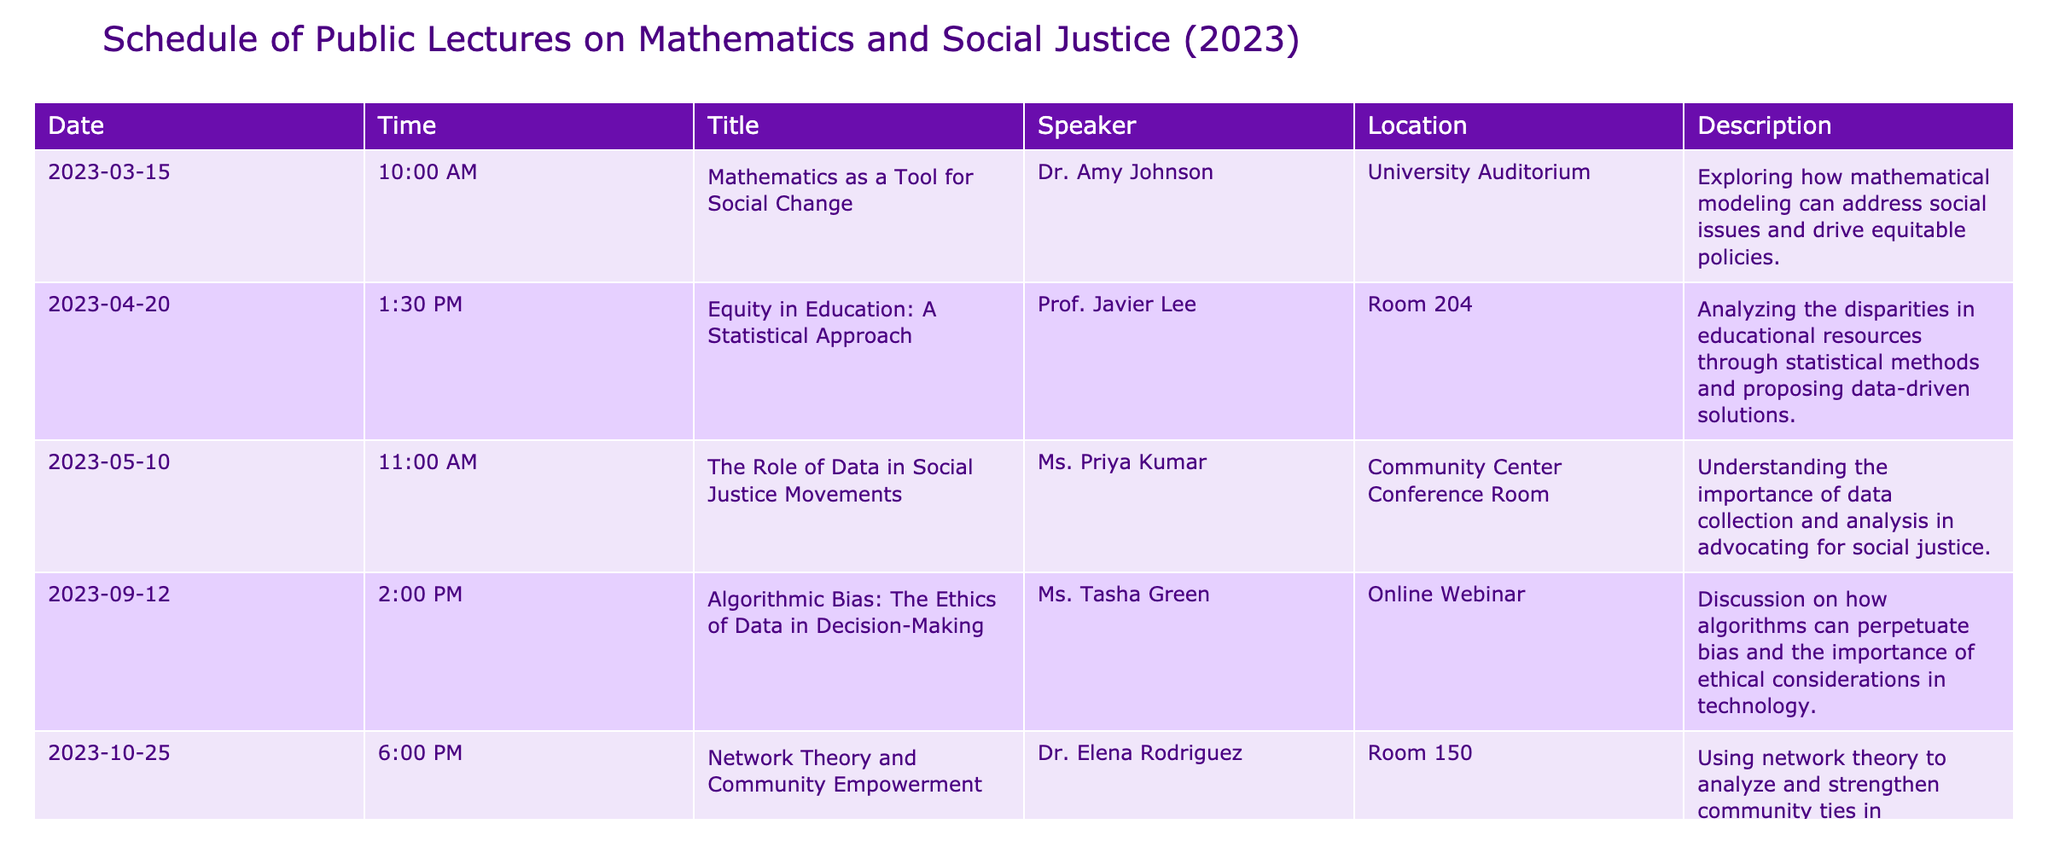What is the title of the lecture scheduled for April 20, 2023? The date of interest is April 20, 2023. By looking in the table, the title listed for that date is "Equity in Education: A Statistical Approach."
Answer: Equity in Education: A Statistical Approach Who is the speaker for the lecture on "The Role of Data in Social Justice Movements"? The relevant title is "The Role of Data in Social Justice Movements." By scanning the table, the speaker for this lecture is identified as Ms. Priya Kumar.
Answer: Ms. Priya Kumar On which date is the lecture about "Algorithmic Bias: The Ethics of Data in Decision-Making" taking place? The title of interest is "Algorithmic Bias: The Ethics of Data in Decision-Making." Looking at the table, this lecture is scheduled for September 12, 2023.
Answer: September 12, 2023 How many lectures are scheduled in the month of May? The lectures in May are "The Role of Data in Social Justice Movements" on May 10, 2023, making it one lecture.
Answer: 1 Is "Network Theory and Community Empowerment" being presented by a female speaker? The speaker for "Network Theory and Community Empowerment" is Dr. Elena Rodriguez. Looking at the gender pronoun typically associated with the name, it is reasonable to conclude she is female.
Answer: Yes Which lecture has the earliest start time and what is that time? The earliest start time can be determined by comparing all listed times in the table. The lecture on March 15, 2023, starts at 10:00 AM, which is earlier than the others.
Answer: 10:00 AM If you attend all these lectures, how many hours will you spend in total? Each lecture lasts approximately one hour; there are five lectures on the schedule. Summing these gives a total time of 5 hours (1 hour per lecture multiplied by 5).
Answer: 5 hours Which location is hosting the lecture on "Equity in Education: A Statistical Approach"? By checking the table, the location for the "Equity in Education: A Statistical Approach" is Room 204.
Answer: Room 204 Are there any lectures that take place online? The table includes a lecture labeled "Algorithmic Bias: The Ethics of Data in Decision-Making" that is marked as an online webinar.
Answer: Yes 